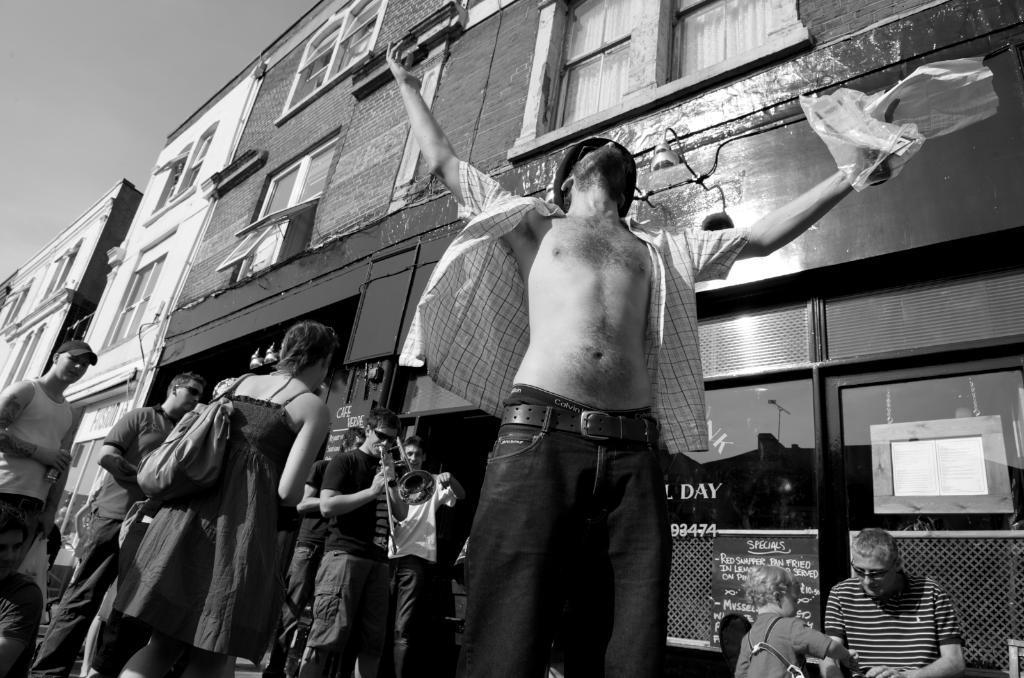In one or two sentences, can you explain what this image depicts? This is a black and white picture. I can see group of people standing, there is a person holding a musical instrument, this is looking like a building, and in the background there is sky. 